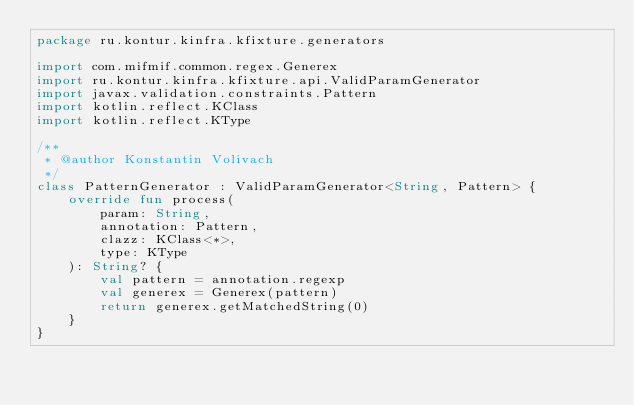<code> <loc_0><loc_0><loc_500><loc_500><_Kotlin_>package ru.kontur.kinfra.kfixture.generators

import com.mifmif.common.regex.Generex
import ru.kontur.kinfra.kfixture.api.ValidParamGenerator
import javax.validation.constraints.Pattern
import kotlin.reflect.KClass
import kotlin.reflect.KType

/**
 * @author Konstantin Volivach
 */
class PatternGenerator : ValidParamGenerator<String, Pattern> {
    override fun process(
        param: String,
        annotation: Pattern,
        clazz: KClass<*>,
        type: KType
    ): String? {
        val pattern = annotation.regexp
        val generex = Generex(pattern)
        return generex.getMatchedString(0)
    }
}</code> 